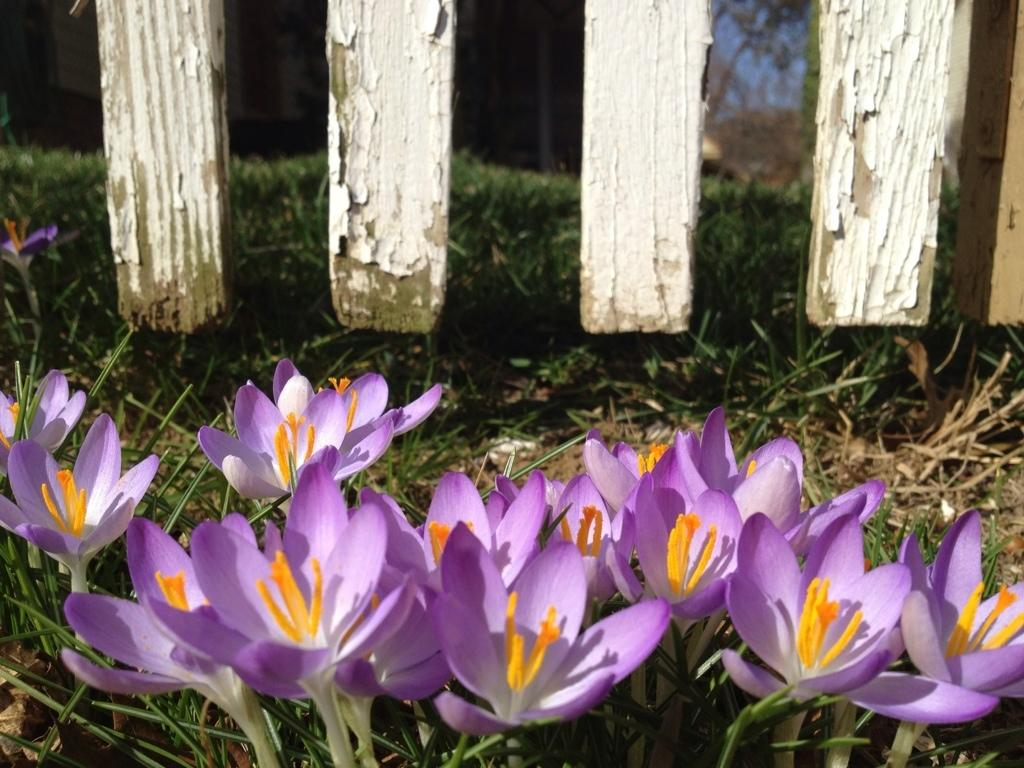What type of vegetation is present at the bottom of the image? There are flowers and grass at the bottom of the image. Can you describe the colors of the flowers? The colors of the flowers cannot be determined from the provided facts. What is the texture of the grass at the bottom of the image? The texture of the grass cannot be determined from the provided facts. What type of car is parked next to the flowers in the image? There is no car present in the image; it only features flowers and grass at the bottom. Can you describe the taste of the eggnog in the image? There is no eggnog present in the image; it only features flowers and grass at the bottom. 